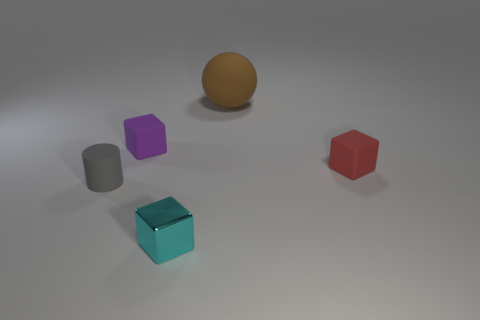Add 4 green shiny spheres. How many objects exist? 9 Subtract all cylinders. How many objects are left? 4 Add 3 metal blocks. How many metal blocks are left? 4 Add 2 tiny green rubber spheres. How many tiny green rubber spheres exist? 2 Subtract 0 blue cubes. How many objects are left? 5 Subtract all large purple metal cylinders. Subtract all small cyan blocks. How many objects are left? 4 